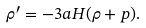Convert formula to latex. <formula><loc_0><loc_0><loc_500><loc_500>\rho ^ { \prime } = - 3 a H ( \rho + p ) .</formula> 